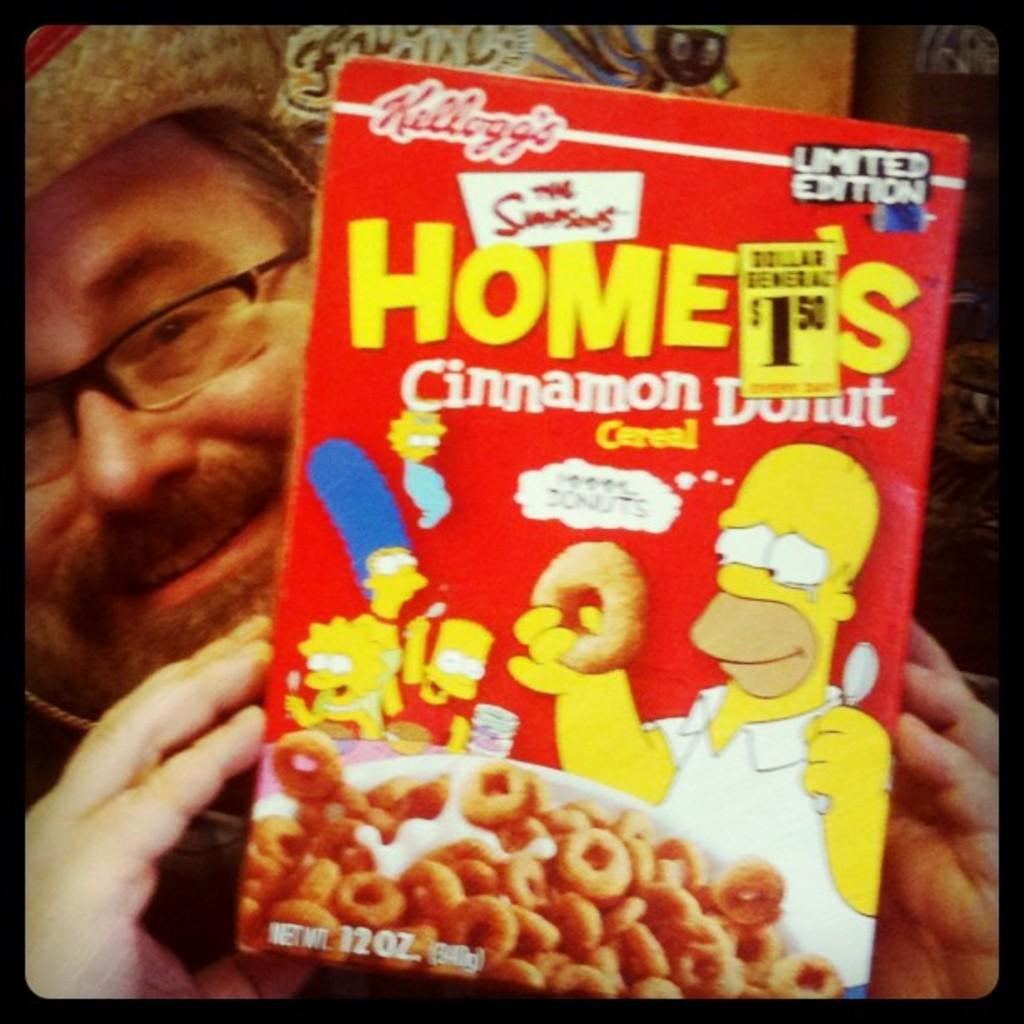What is the man in the image wearing on his face? The man is wearing spectacles. What type of headwear is the man wearing in the image? The man is wearing a hat. What is the man holding in the image? The man is holding a red color doughnut box. What is the man's facial expression in the image? The man is smiling. What type of space suit is the man wearing in the image? The man is not wearing a space suit in the image; he is wearing a hat and spectacles. What is the man using to apply lipstick in the image? There is no lipstick or application tool present in the image. 